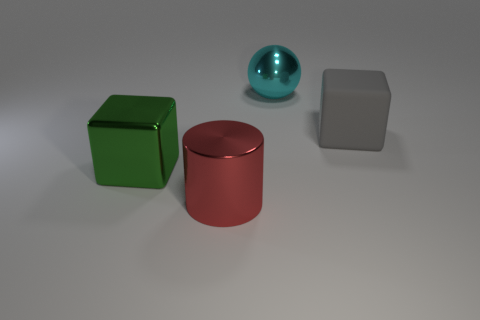Subtract all green cubes. How many cubes are left? 1 Subtract 2 blocks. How many blocks are left? 0 Subtract all shiny cubes. Subtract all matte blocks. How many objects are left? 2 Add 3 big red things. How many big red things are left? 4 Add 3 rubber blocks. How many rubber blocks exist? 4 Add 1 yellow matte things. How many objects exist? 5 Subtract 0 yellow cylinders. How many objects are left? 4 Subtract all purple blocks. Subtract all green balls. How many blocks are left? 2 Subtract all green cylinders. How many cyan cubes are left? 0 